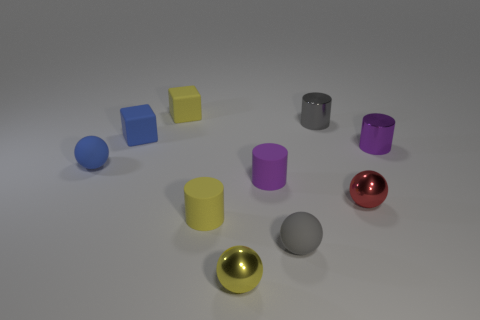What number of things are either rubber blocks on the left side of the yellow block or cylinders in front of the tiny gray cylinder? There are three rubber blocks to the left side of the yellow block and one tiny red cylinder in front of the tiny gray cylinder, making a total of four items that fit the criteria given. 